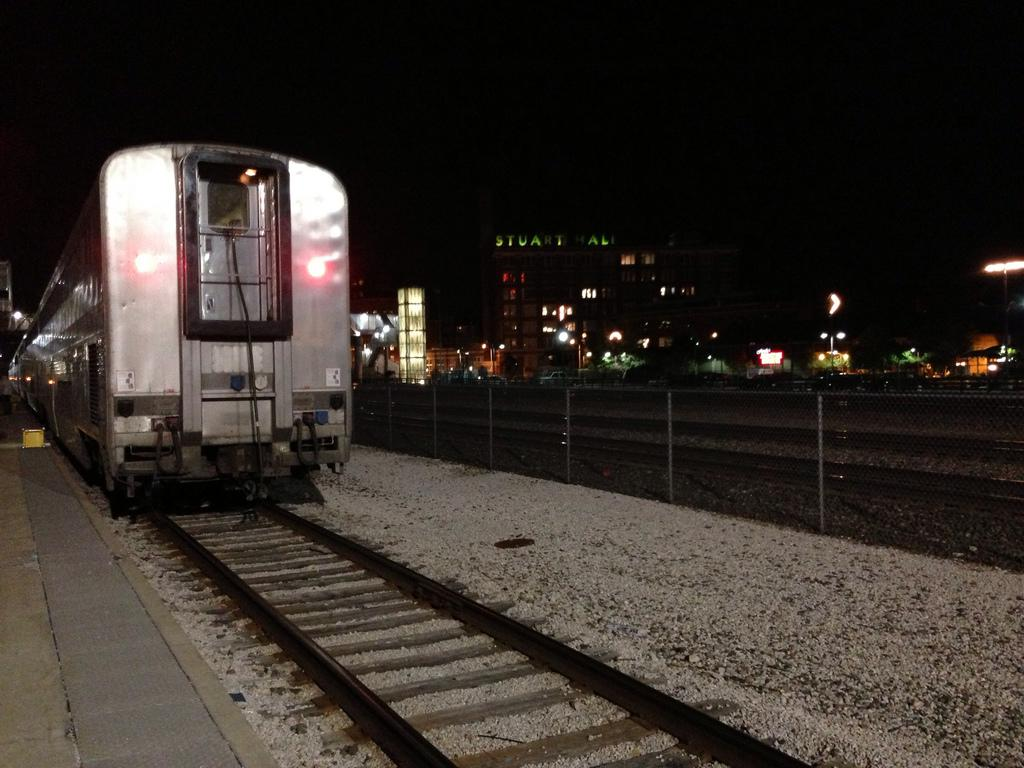Question: where is this picture taken?
Choices:
A. In a zoo.
B. In a park.
C. Train station.
D. In a pool.
Answer with the letter. Answer: C Question: what time of day is this?
Choices:
A. Noon.
B. Morning.
C. Night time.
D. Evening.
Answer with the letter. Answer: C Question: what color is the train?
Choices:
A. Red.
B. Blue.
C. Green.
D. Silver.
Answer with the letter. Answer: D Question: what is the train on?
Choices:
A. The station.
B. Railway.
C. Road.
D. Railroad track.
Answer with the letter. Answer: D Question: where is the train on the picture?
Choices:
A. In front.
B. The left.
C. On the right.
D. At the back.
Answer with the letter. Answer: B Question: what sits on tracks with tall lighted buildings in the night behind?
Choices:
A. A trolley.
B. A carnival ride.
C. An old steam engine.
D. A silver train.
Answer with the letter. Answer: D Question: who is standing near the train?
Choices:
A. A crowd of waiting passengers.
B. Men in dark business suits.
C. No one.
D. A mother and her two kids.
Answer with the letter. Answer: C Question: what surrounds the tracks?
Choices:
A. Trees.
B. Gravel.
C. Bushes.
D. Stands.
Answer with the letter. Answer: B Question: what time of day is it?
Choices:
A. Morning.
B. Noon.
C. Night.
D. Afternoon.
Answer with the letter. Answer: C Question: what color trim does the train have?
Choices:
A. Yellow.
B. White.
C. Black.
D. Orange.
Answer with the letter. Answer: C Question: how many lights does the train have?
Choices:
A. One.
B. Three.
C. Two.
D. Four.
Answer with the letter. Answer: C Question: what is laid on wooden tiles?
Choices:
A. A rug.
B. A mat.
C. Tracks.
D. A dog bed.
Answer with the letter. Answer: C Question: what is made with square blocks?
Choices:
A. Walkway next to train.
B. Sidewalk.
C. House.
D. Office.
Answer with the letter. Answer: A Question: what color is the track?
Choices:
A. White.
B. Black.
C. Tan.
D. Blue.
Answer with the letter. Answer: B Question: where does the train have its lights on?
Choices:
A. At the front.
B. In passenger compartment.
C. On top.
D. In the rear.
Answer with the letter. Answer: D Question: when was this picture taken?
Choices:
A. Sunset.
B. Sunrise.
C. Nighttime.
D. Last week.
Answer with the letter. Answer: C Question: how is it dark outside?
Choices:
A. Dusk.
B. Middle of the night.
C. It's nighttime.
D. Early evening.
Answer with the letter. Answer: C Question: what has its lights on?
Choices:
A. The train.
B. The truck.
C. The bicycle.
D. The museum.
Answer with the letter. Answer: A 